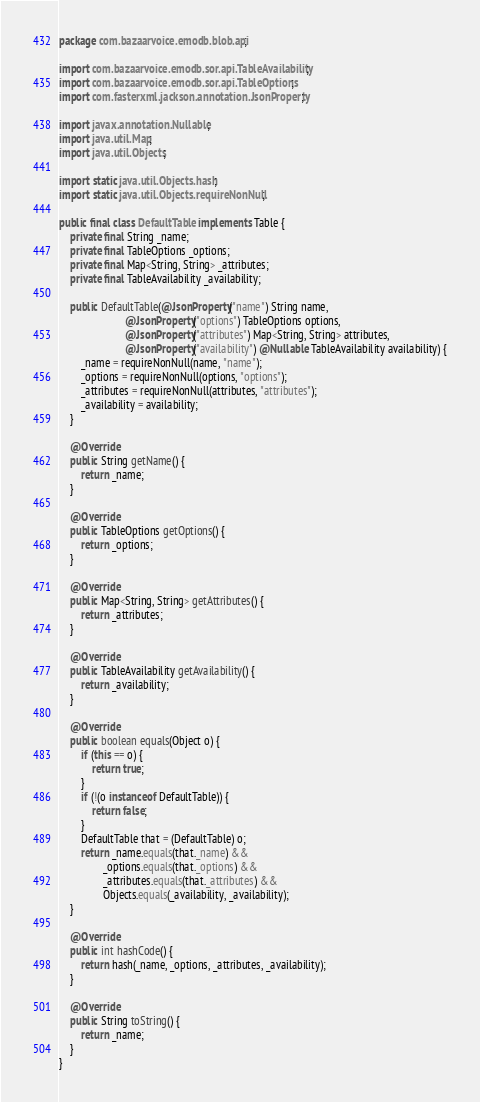<code> <loc_0><loc_0><loc_500><loc_500><_Java_>package com.bazaarvoice.emodb.blob.api;

import com.bazaarvoice.emodb.sor.api.TableAvailability;
import com.bazaarvoice.emodb.sor.api.TableOptions;
import com.fasterxml.jackson.annotation.JsonProperty;

import javax.annotation.Nullable;
import java.util.Map;
import java.util.Objects;

import static java.util.Objects.hash;
import static java.util.Objects.requireNonNull;

public final class DefaultTable implements Table {
    private final String _name;
    private final TableOptions _options;
    private final Map<String, String> _attributes;
    private final TableAvailability _availability;

    public DefaultTable(@JsonProperty("name") String name,
                        @JsonProperty("options") TableOptions options,
                        @JsonProperty("attributes") Map<String, String> attributes,
                        @JsonProperty("availability") @Nullable TableAvailability availability) {
        _name = requireNonNull(name, "name");
        _options = requireNonNull(options, "options");
        _attributes = requireNonNull(attributes, "attributes");
        _availability = availability;
    }

    @Override
    public String getName() {
        return _name;
    }

    @Override
    public TableOptions getOptions() {
        return _options;
    }

    @Override
    public Map<String, String> getAttributes() {
        return _attributes;
    }

    @Override
    public TableAvailability getAvailability() {
        return _availability;
    }

    @Override
    public boolean equals(Object o) {
        if (this == o) {
            return true;
        }
        if (!(o instanceof DefaultTable)) {
            return false;
        }
        DefaultTable that = (DefaultTable) o;
        return _name.equals(that._name) &&
                _options.equals(that._options) &&
                _attributes.equals(that._attributes) &&
                Objects.equals(_availability, _availability);
    }

    @Override
    public int hashCode() {
        return hash(_name, _options, _attributes, _availability);
    }

    @Override
    public String toString() {
        return _name;
    }
}
</code> 